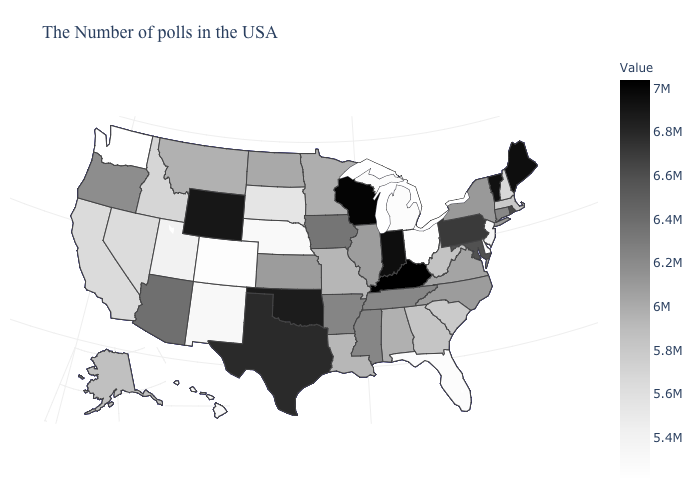Among the states that border Connecticut , which have the lowest value?
Give a very brief answer. Massachusetts. Among the states that border Arkansas , does Texas have the highest value?
Give a very brief answer. No. Which states have the lowest value in the USA?
Keep it brief. Washington. Does the map have missing data?
Be succinct. No. Does Wisconsin have the highest value in the MidWest?
Short answer required. Yes. 